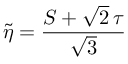<formula> <loc_0><loc_0><loc_500><loc_500>\tilde { \eta } = { \frac { S + \sqrt { 2 } \, \tau } { \sqrt { 3 } } }</formula> 